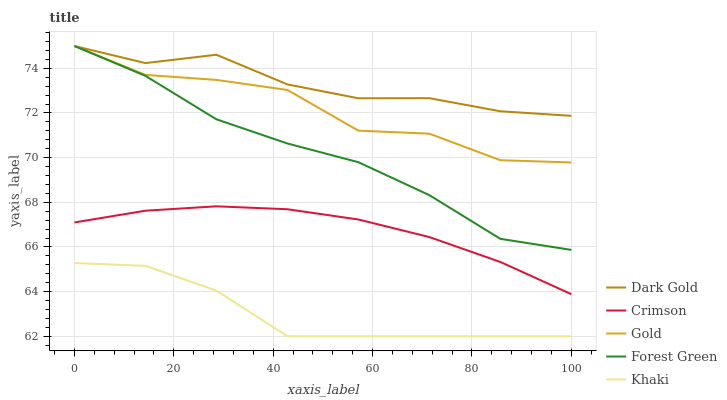Does Khaki have the minimum area under the curve?
Answer yes or no. Yes. Does Dark Gold have the maximum area under the curve?
Answer yes or no. Yes. Does Forest Green have the minimum area under the curve?
Answer yes or no. No. Does Forest Green have the maximum area under the curve?
Answer yes or no. No. Is Crimson the smoothest?
Answer yes or no. Yes. Is Gold the roughest?
Answer yes or no. Yes. Is Forest Green the smoothest?
Answer yes or no. No. Is Forest Green the roughest?
Answer yes or no. No. Does Forest Green have the lowest value?
Answer yes or no. No. Does Dark Gold have the highest value?
Answer yes or no. Yes. Does Khaki have the highest value?
Answer yes or no. No. Is Crimson less than Gold?
Answer yes or no. Yes. Is Gold greater than Khaki?
Answer yes or no. Yes. Does Gold intersect Dark Gold?
Answer yes or no. Yes. Is Gold less than Dark Gold?
Answer yes or no. No. Is Gold greater than Dark Gold?
Answer yes or no. No. Does Crimson intersect Gold?
Answer yes or no. No. 